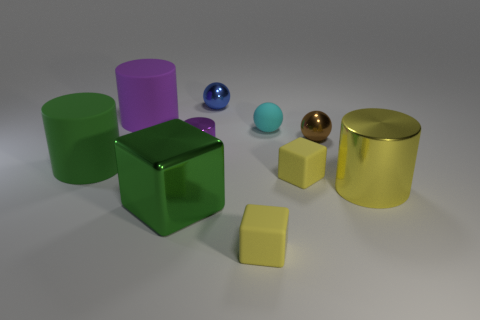There is a metallic cylinder to the right of the purple metallic thing; is its color the same as the big thing that is in front of the big metal cylinder?
Your answer should be very brief. No. What color is the large rubber cylinder behind the small cylinder?
Offer a very short reply. Purple. Does the cyan object that is behind the brown shiny thing have the same size as the small purple shiny cylinder?
Provide a short and direct response. Yes. Is the number of small metal objects less than the number of small cubes?
Keep it short and to the point. No. There is a thing that is the same color as the big cube; what is its shape?
Provide a short and direct response. Cylinder. What number of tiny blocks are right of the brown metal ball?
Your response must be concise. 0. Is the shape of the big yellow metallic object the same as the small purple metallic thing?
Provide a short and direct response. Yes. How many things are both in front of the green rubber object and on the right side of the small shiny cylinder?
Provide a short and direct response. 3. How many things are cyan shiny blocks or large matte objects that are on the left side of the purple rubber object?
Your response must be concise. 1. Is the number of big blue cylinders greater than the number of large metal cylinders?
Provide a short and direct response. No. 